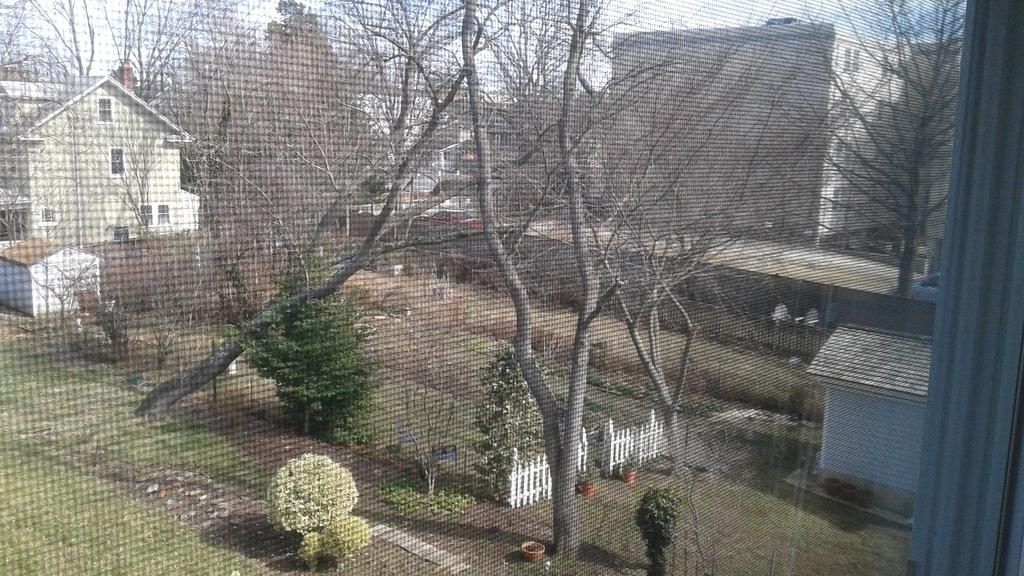What can be seen in the sky in the image? The sky is visible in the image. What type of vegetation is present in the image? There are trees and bushes in the image. What type of barrier is present in the image? There is a wooden fence in the image. What type of indoor plants can be seen in the image? Houseplants are visible in the image. What type of structures are present in the image? There are sheds in the image. What can be seen through the mesh of a window in the image? Iron grills are observable through the mesh of a window. How many bags can be seen hanging from the trees in the image? There are no bags present in the image; it features trees, bushes, a wooden fence, houseplants, sheds, and iron grills. What type of amphibian can be seen hopping around in the image? There are no amphibians present in the image; it features trees, bushes, a wooden fence, houseplants, sheds, and iron grills. 